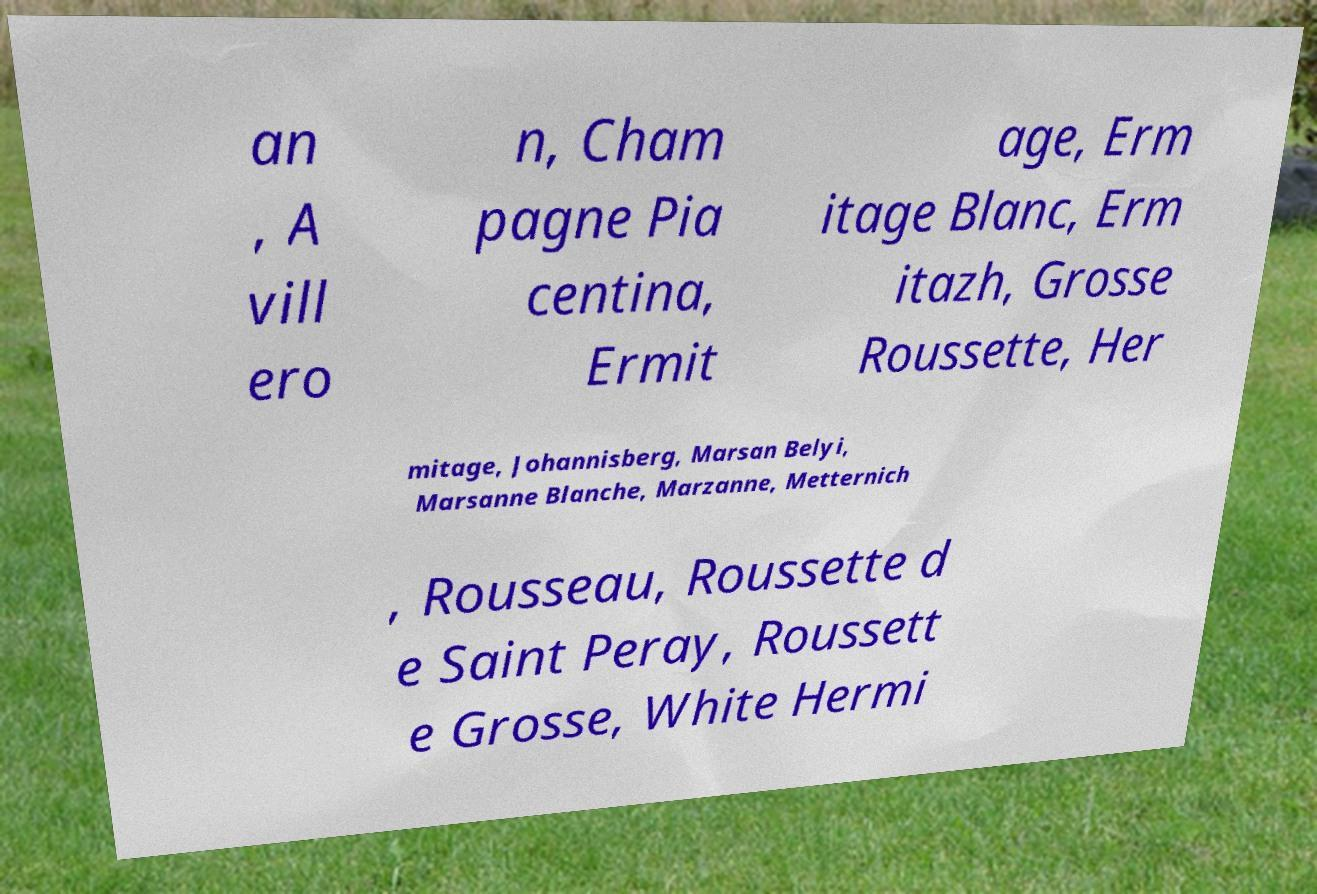Please read and relay the text visible in this image. What does it say? an , A vill ero n, Cham pagne Pia centina, Ermit age, Erm itage Blanc, Erm itazh, Grosse Roussette, Her mitage, Johannisberg, Marsan Belyi, Marsanne Blanche, Marzanne, Metternich , Rousseau, Roussette d e Saint Peray, Roussett e Grosse, White Hermi 